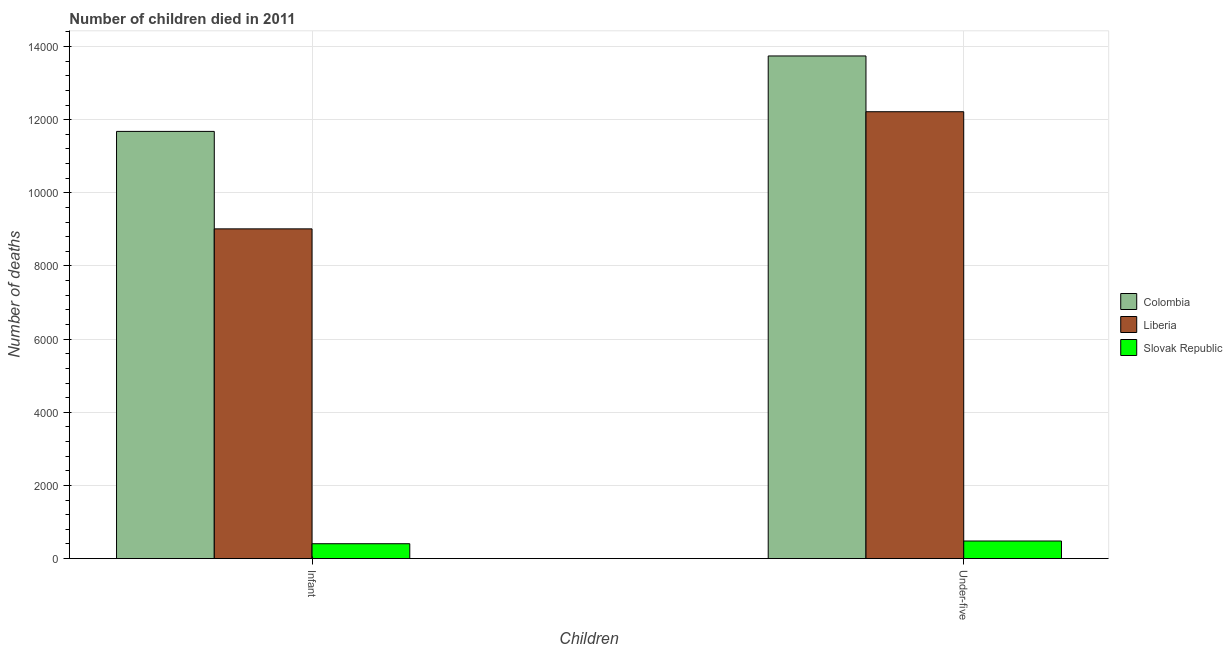How many different coloured bars are there?
Keep it short and to the point. 3. How many bars are there on the 2nd tick from the left?
Ensure brevity in your answer.  3. What is the label of the 1st group of bars from the left?
Ensure brevity in your answer.  Infant. What is the number of infant deaths in Colombia?
Offer a very short reply. 1.17e+04. Across all countries, what is the maximum number of infant deaths?
Ensure brevity in your answer.  1.17e+04. Across all countries, what is the minimum number of under-five deaths?
Ensure brevity in your answer.  480. In which country was the number of under-five deaths minimum?
Offer a terse response. Slovak Republic. What is the total number of under-five deaths in the graph?
Offer a very short reply. 2.64e+04. What is the difference between the number of infant deaths in Colombia and that in Slovak Republic?
Provide a succinct answer. 1.13e+04. What is the difference between the number of under-five deaths in Colombia and the number of infant deaths in Slovak Republic?
Offer a terse response. 1.33e+04. What is the average number of under-five deaths per country?
Keep it short and to the point. 8813.67. What is the difference between the number of under-five deaths and number of infant deaths in Slovak Republic?
Keep it short and to the point. 74. In how many countries, is the number of under-five deaths greater than 1200 ?
Make the answer very short. 2. What is the ratio of the number of under-five deaths in Liberia to that in Colombia?
Ensure brevity in your answer.  0.89. What does the 2nd bar from the left in Under-five represents?
Offer a terse response. Liberia. What does the 1st bar from the right in Infant represents?
Offer a very short reply. Slovak Republic. How many bars are there?
Your answer should be very brief. 6. Does the graph contain any zero values?
Offer a very short reply. No. Where does the legend appear in the graph?
Provide a succinct answer. Center right. How many legend labels are there?
Offer a very short reply. 3. How are the legend labels stacked?
Make the answer very short. Vertical. What is the title of the graph?
Your response must be concise. Number of children died in 2011. What is the label or title of the X-axis?
Your answer should be very brief. Children. What is the label or title of the Y-axis?
Offer a terse response. Number of deaths. What is the Number of deaths of Colombia in Infant?
Ensure brevity in your answer.  1.17e+04. What is the Number of deaths of Liberia in Infant?
Your answer should be very brief. 9015. What is the Number of deaths in Slovak Republic in Infant?
Give a very brief answer. 406. What is the Number of deaths in Colombia in Under-five?
Provide a succinct answer. 1.37e+04. What is the Number of deaths of Liberia in Under-five?
Keep it short and to the point. 1.22e+04. What is the Number of deaths of Slovak Republic in Under-five?
Ensure brevity in your answer.  480. Across all Children, what is the maximum Number of deaths of Colombia?
Your response must be concise. 1.37e+04. Across all Children, what is the maximum Number of deaths of Liberia?
Give a very brief answer. 1.22e+04. Across all Children, what is the maximum Number of deaths of Slovak Republic?
Your answer should be compact. 480. Across all Children, what is the minimum Number of deaths in Colombia?
Keep it short and to the point. 1.17e+04. Across all Children, what is the minimum Number of deaths of Liberia?
Provide a succinct answer. 9015. Across all Children, what is the minimum Number of deaths of Slovak Republic?
Provide a short and direct response. 406. What is the total Number of deaths in Colombia in the graph?
Make the answer very short. 2.54e+04. What is the total Number of deaths of Liberia in the graph?
Provide a short and direct response. 2.12e+04. What is the total Number of deaths of Slovak Republic in the graph?
Your answer should be compact. 886. What is the difference between the Number of deaths of Colombia in Infant and that in Under-five?
Keep it short and to the point. -2063. What is the difference between the Number of deaths in Liberia in Infant and that in Under-five?
Offer a terse response. -3203. What is the difference between the Number of deaths in Slovak Republic in Infant and that in Under-five?
Offer a very short reply. -74. What is the difference between the Number of deaths of Colombia in Infant and the Number of deaths of Liberia in Under-five?
Your response must be concise. -538. What is the difference between the Number of deaths in Colombia in Infant and the Number of deaths in Slovak Republic in Under-five?
Keep it short and to the point. 1.12e+04. What is the difference between the Number of deaths of Liberia in Infant and the Number of deaths of Slovak Republic in Under-five?
Keep it short and to the point. 8535. What is the average Number of deaths of Colombia per Children?
Offer a terse response. 1.27e+04. What is the average Number of deaths in Liberia per Children?
Your response must be concise. 1.06e+04. What is the average Number of deaths in Slovak Republic per Children?
Provide a succinct answer. 443. What is the difference between the Number of deaths in Colombia and Number of deaths in Liberia in Infant?
Ensure brevity in your answer.  2665. What is the difference between the Number of deaths in Colombia and Number of deaths in Slovak Republic in Infant?
Provide a succinct answer. 1.13e+04. What is the difference between the Number of deaths of Liberia and Number of deaths of Slovak Republic in Infant?
Your answer should be compact. 8609. What is the difference between the Number of deaths of Colombia and Number of deaths of Liberia in Under-five?
Your answer should be compact. 1525. What is the difference between the Number of deaths of Colombia and Number of deaths of Slovak Republic in Under-five?
Offer a very short reply. 1.33e+04. What is the difference between the Number of deaths of Liberia and Number of deaths of Slovak Republic in Under-five?
Keep it short and to the point. 1.17e+04. What is the ratio of the Number of deaths of Colombia in Infant to that in Under-five?
Give a very brief answer. 0.85. What is the ratio of the Number of deaths of Liberia in Infant to that in Under-five?
Your answer should be compact. 0.74. What is the ratio of the Number of deaths of Slovak Republic in Infant to that in Under-five?
Your response must be concise. 0.85. What is the difference between the highest and the second highest Number of deaths of Colombia?
Your response must be concise. 2063. What is the difference between the highest and the second highest Number of deaths of Liberia?
Offer a terse response. 3203. What is the difference between the highest and the second highest Number of deaths in Slovak Republic?
Offer a very short reply. 74. What is the difference between the highest and the lowest Number of deaths in Colombia?
Your response must be concise. 2063. What is the difference between the highest and the lowest Number of deaths in Liberia?
Make the answer very short. 3203. 